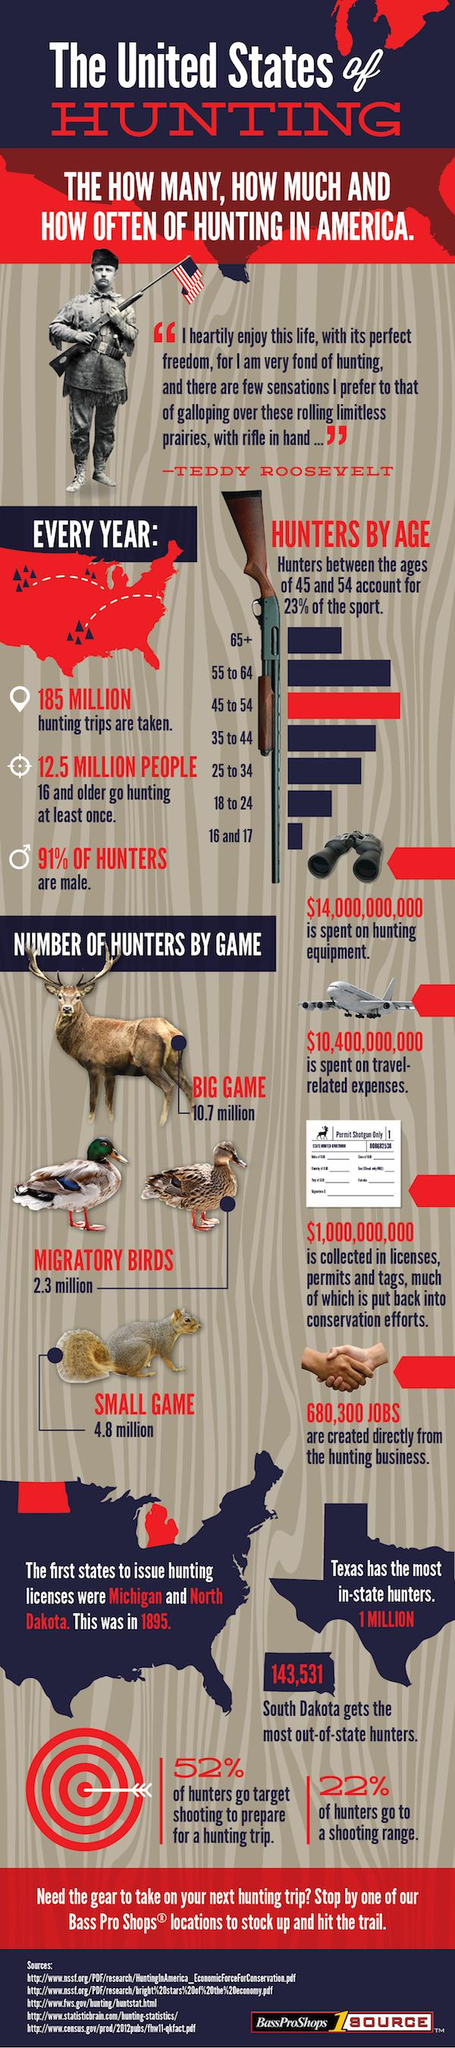Identify some key points in this picture. The 55 to 64 age group accounts for the second highest number of hunters. 